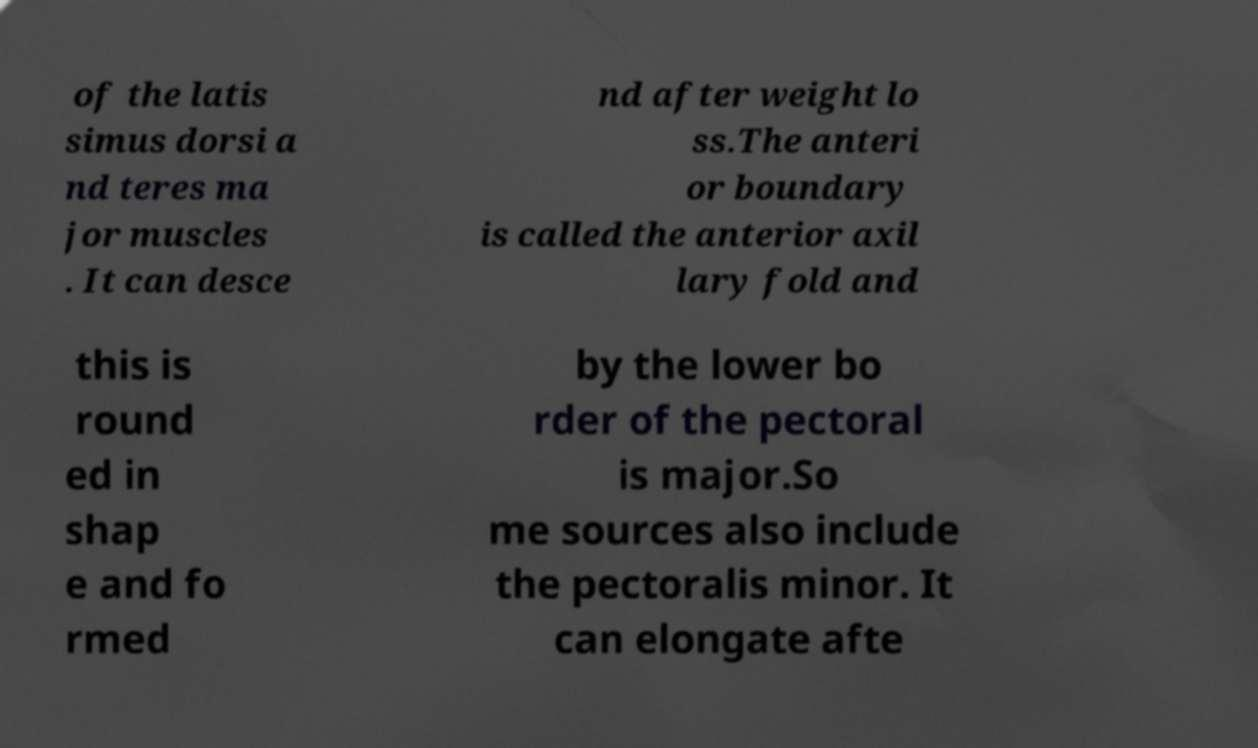Could you extract and type out the text from this image? of the latis simus dorsi a nd teres ma jor muscles . It can desce nd after weight lo ss.The anteri or boundary is called the anterior axil lary fold and this is round ed in shap e and fo rmed by the lower bo rder of the pectoral is major.So me sources also include the pectoralis minor. It can elongate afte 